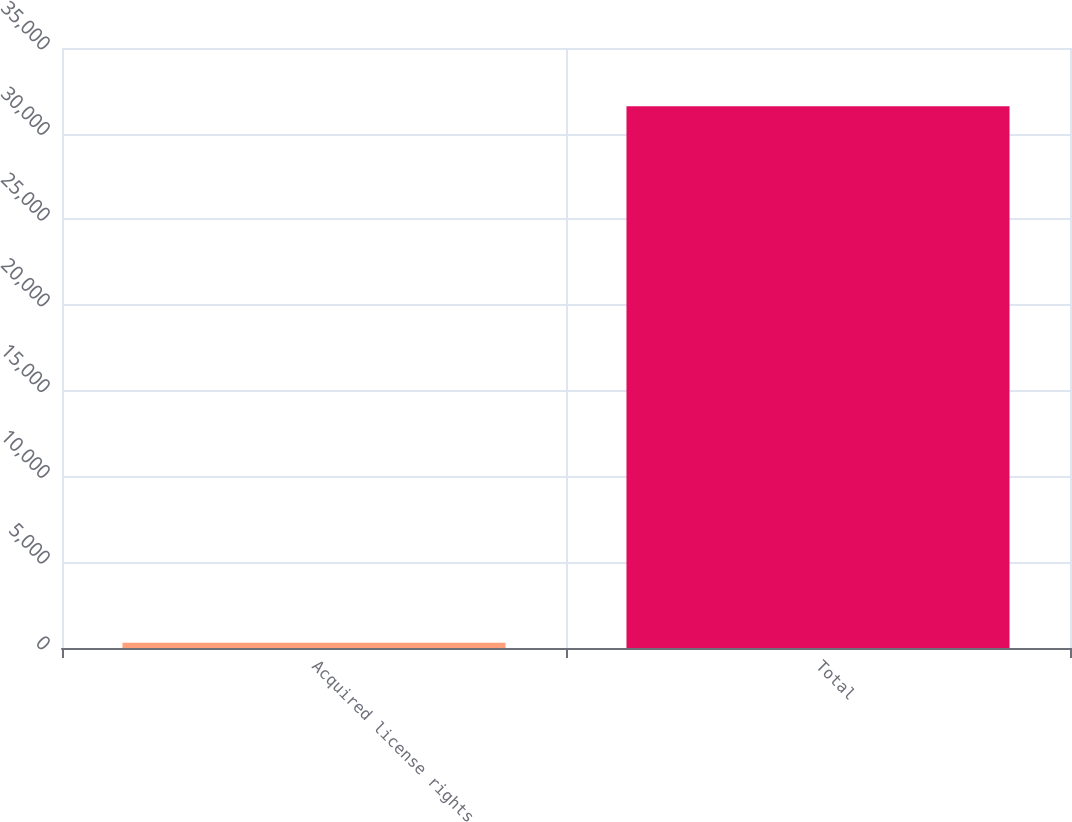Convert chart to OTSL. <chart><loc_0><loc_0><loc_500><loc_500><bar_chart><fcel>Acquired license rights<fcel>Total<nl><fcel>299<fcel>31595<nl></chart> 